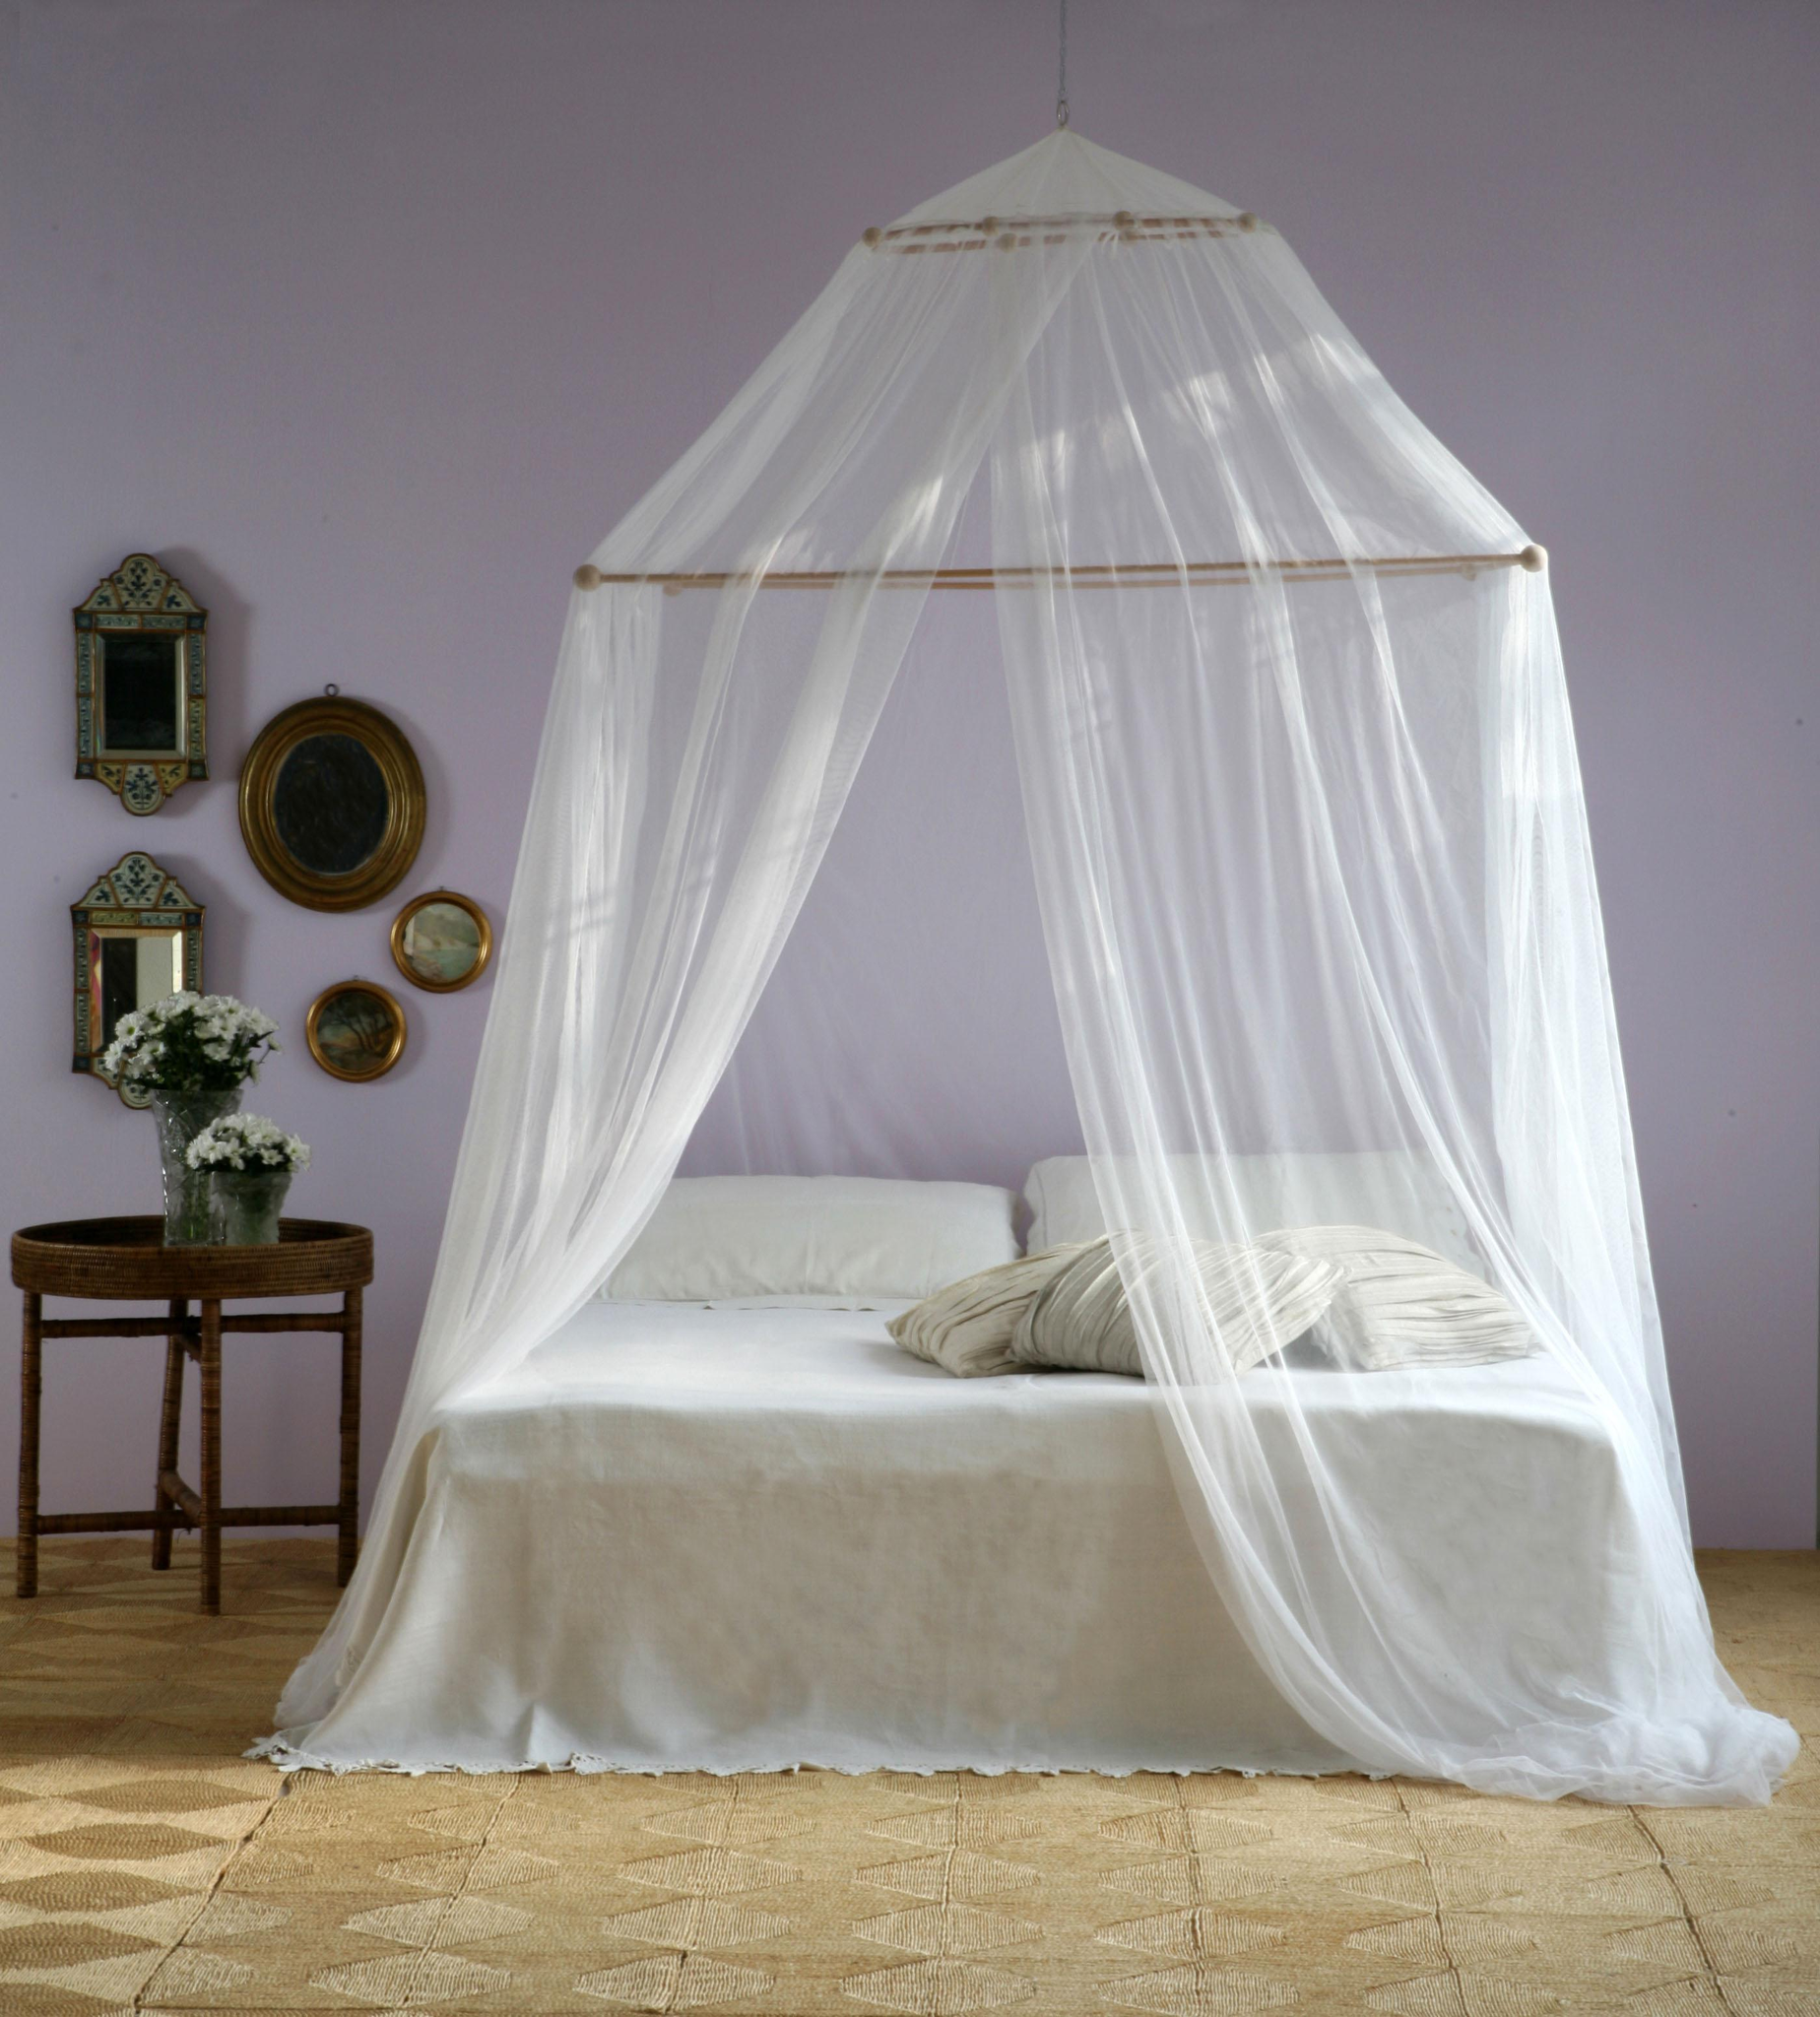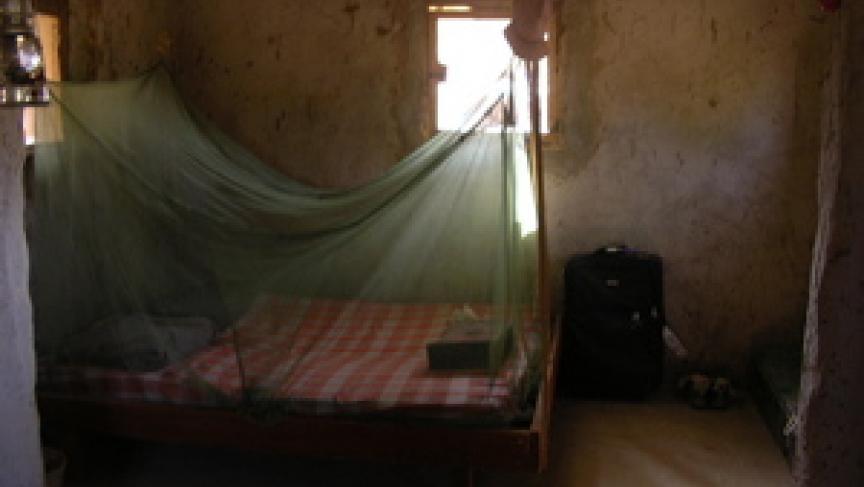The first image is the image on the left, the second image is the image on the right. For the images shown, is this caption "One image shows a gauzy pale canopy that drapes a bed from a round shape suspended from the ceiling, and the other image shows a canopy suspended from four corners." true? Answer yes or no. Yes. The first image is the image on the left, the second image is the image on the right. Examine the images to the left and right. Is the description "There is a round canopy bed in the right image." accurate? Answer yes or no. No. 